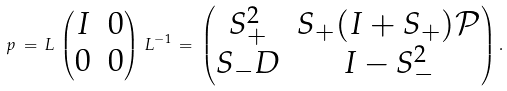<formula> <loc_0><loc_0><loc_500><loc_500>p \, = \, L \, \begin{pmatrix} I & 0 \\ 0 & 0 \end{pmatrix} \, L ^ { - 1 } \, = \, \begin{pmatrix} S _ { + } ^ { 2 } & S _ { + } ( I + S _ { + } ) { \mathcal { P } } \\ S _ { - } D & I - S _ { - } ^ { 2 } \end{pmatrix} .</formula> 